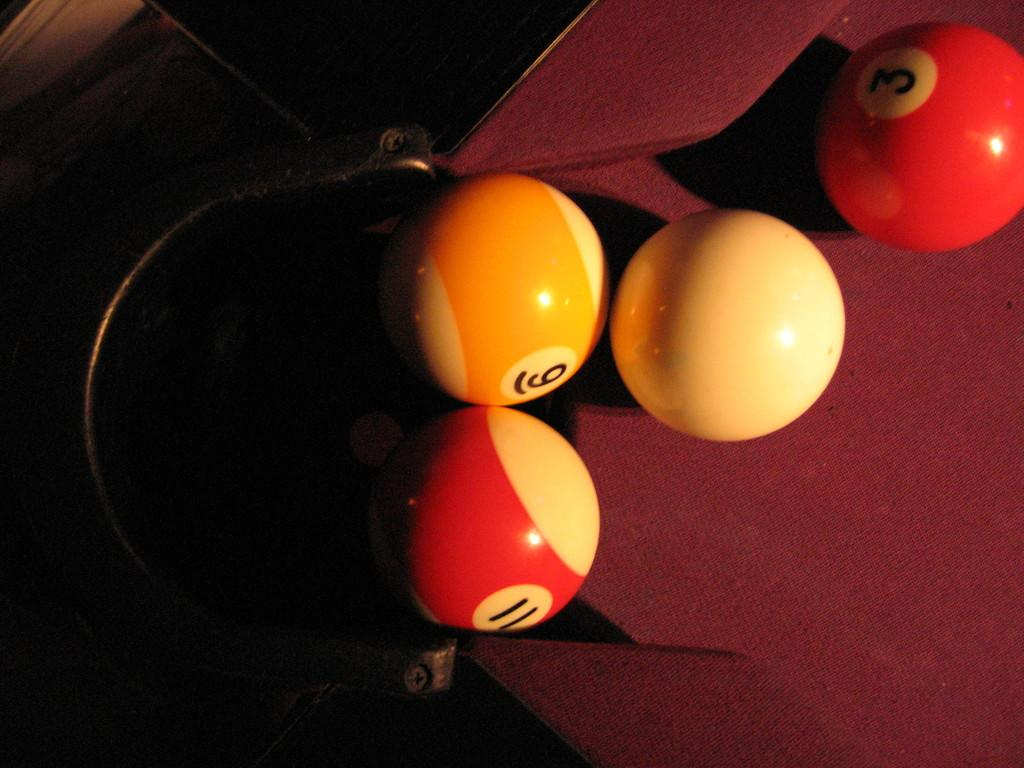<image>
Summarize the visual content of the image. Balls with numbers 3, 6 and ii are on the pool table with a white ball. 